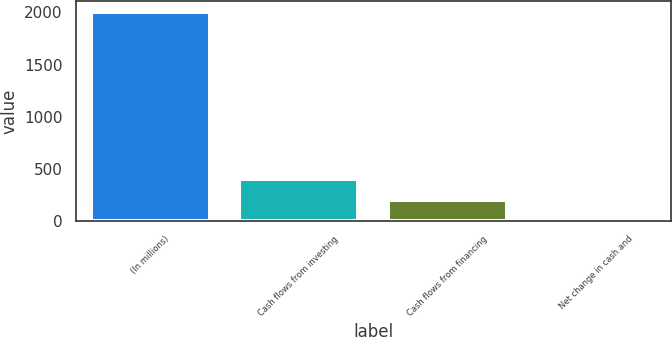Convert chart. <chart><loc_0><loc_0><loc_500><loc_500><bar_chart><fcel>(In millions)<fcel>Cash flows from investing<fcel>Cash flows from financing<fcel>Net change in cash and<nl><fcel>2007<fcel>404.6<fcel>204.3<fcel>4<nl></chart> 